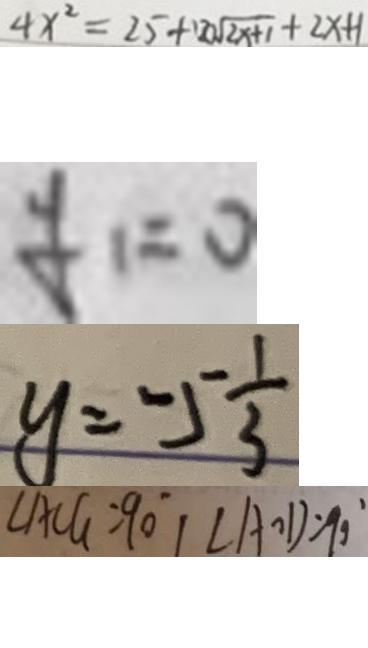<formula> <loc_0><loc_0><loc_500><loc_500>4 x ^ { 2 } = 2 5 + 1 2 0 \sqrt { 2 x + 1 } + 2 x + 1 
 y _ { 1 } = 0 
 y = - 5 \frac { 1 } { 3 } 
 \angle A C G = 9 0 ^ { \circ } ( \angle A O D = 9 0 ^ { \circ }</formula> 